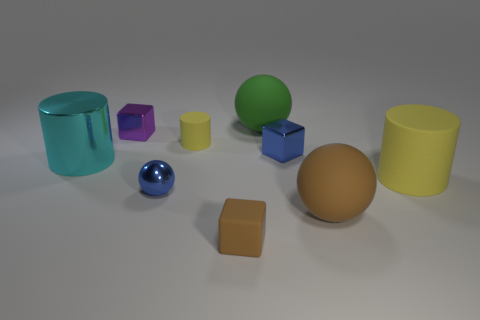Is there a tiny metal thing that has the same color as the metal ball?
Your response must be concise. Yes. There is a tiny rubber cylinder; is its color the same as the large cylinder that is right of the small purple shiny thing?
Keep it short and to the point. Yes. The small matte object that is the same color as the big rubber cylinder is what shape?
Give a very brief answer. Cylinder. Does the tiny cylinder have the same color as the big matte cylinder?
Your answer should be compact. Yes. Do the matte cylinder behind the large yellow rubber thing and the big rubber cylinder have the same color?
Provide a succinct answer. Yes. Is the number of metallic objects in front of the large rubber cylinder greater than the number of small green things?
Your answer should be compact. Yes. Do the cyan thing and the matte cube have the same size?
Your response must be concise. No. There is a big brown thing that is the same shape as the big green thing; what is it made of?
Ensure brevity in your answer.  Rubber. Is there anything else that is made of the same material as the large brown thing?
Offer a very short reply. Yes. What number of blue things are either small cubes or tiny rubber things?
Ensure brevity in your answer.  1. 